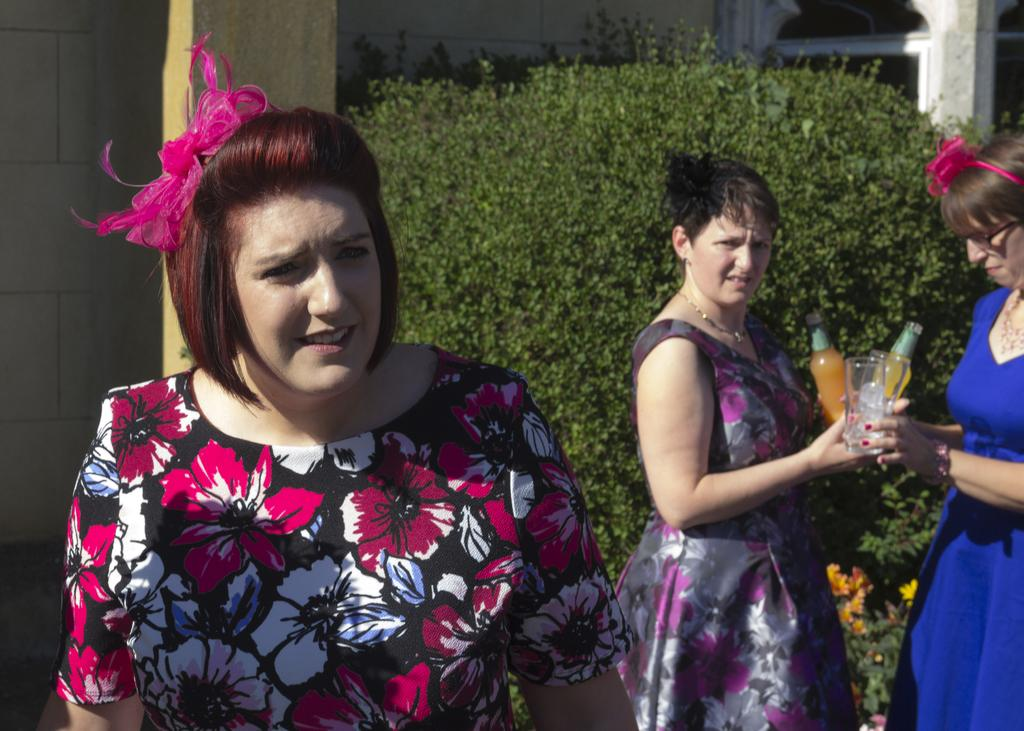What is the main subject of the image? There is a woman in the image. Are there any other people in the image? Yes, there are other women standing behind the first woman. What are the women holding in the image? The women are holding bottles. What can be seen in the background of the image? There are plants visible in the image. How many lizards can be seen on the woman's hat in the image? There is no hat or lizards present in the image. 